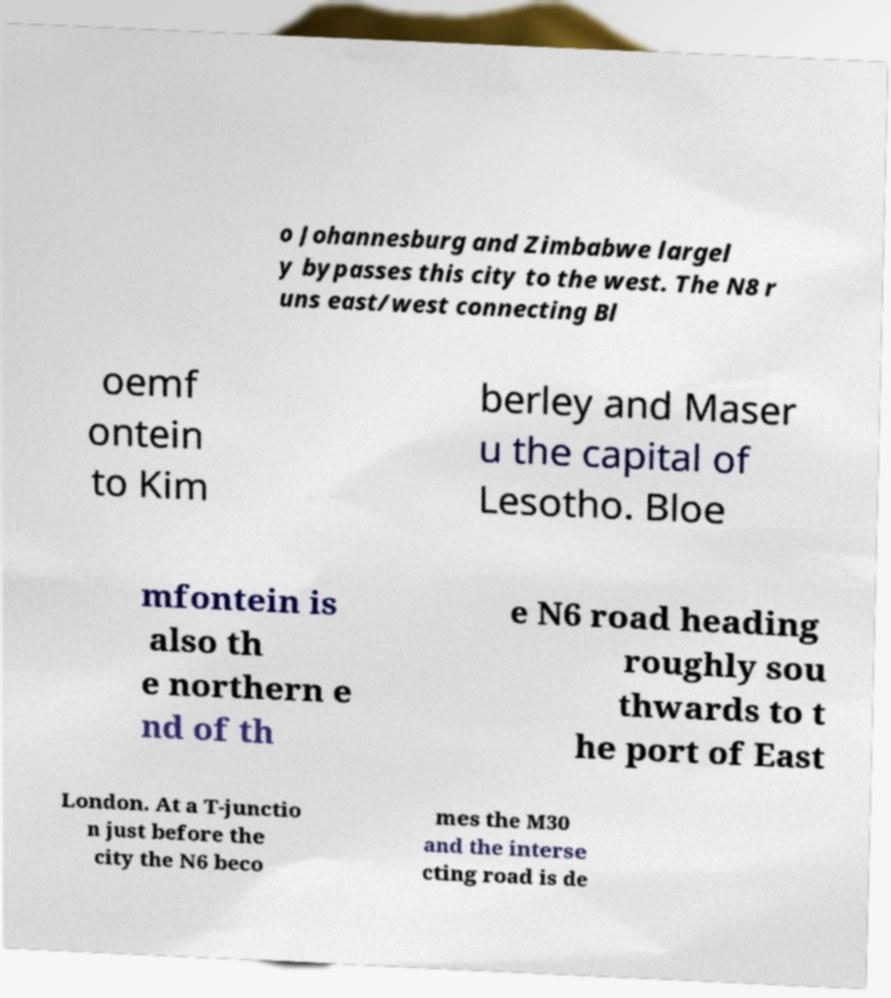Please identify and transcribe the text found in this image. o Johannesburg and Zimbabwe largel y bypasses this city to the west. The N8 r uns east/west connecting Bl oemf ontein to Kim berley and Maser u the capital of Lesotho. Bloe mfontein is also th e northern e nd of th e N6 road heading roughly sou thwards to t he port of East London. At a T-junctio n just before the city the N6 beco mes the M30 and the interse cting road is de 